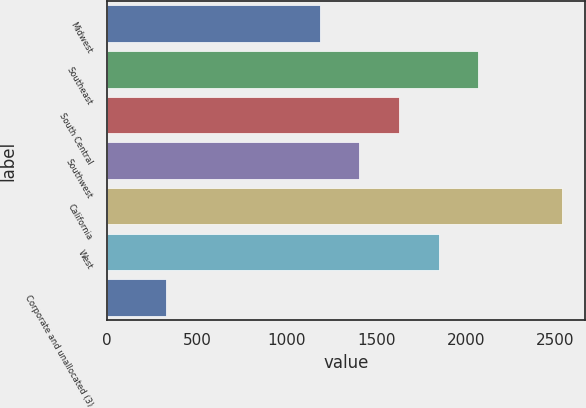Convert chart to OTSL. <chart><loc_0><loc_0><loc_500><loc_500><bar_chart><fcel>Midwest<fcel>Southeast<fcel>South Central<fcel>Southwest<fcel>California<fcel>West<fcel>Corporate and unallocated (3)<nl><fcel>1185.1<fcel>2068.54<fcel>1626.82<fcel>1405.96<fcel>2535.7<fcel>1847.68<fcel>327.1<nl></chart> 